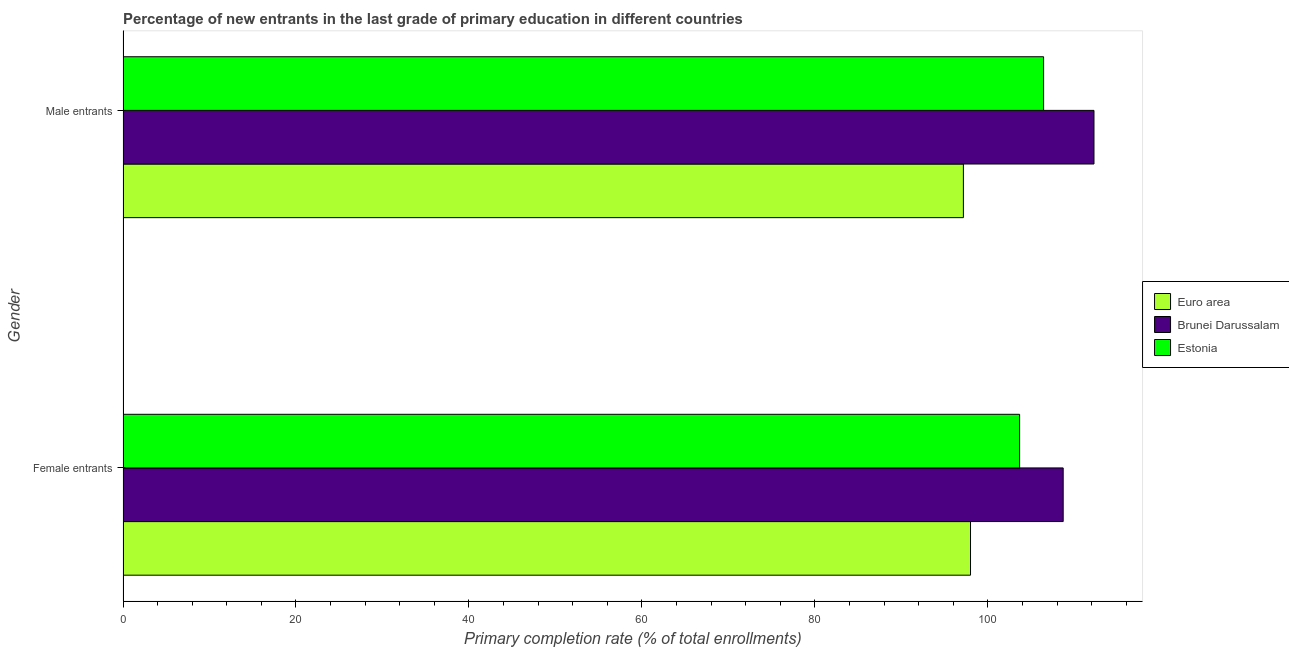How many different coloured bars are there?
Make the answer very short. 3. Are the number of bars per tick equal to the number of legend labels?
Give a very brief answer. Yes. Are the number of bars on each tick of the Y-axis equal?
Your answer should be compact. Yes. How many bars are there on the 2nd tick from the bottom?
Provide a succinct answer. 3. What is the label of the 2nd group of bars from the top?
Your answer should be very brief. Female entrants. What is the primary completion rate of male entrants in Brunei Darussalam?
Make the answer very short. 112.26. Across all countries, what is the maximum primary completion rate of female entrants?
Your answer should be very brief. 108.7. Across all countries, what is the minimum primary completion rate of male entrants?
Provide a succinct answer. 97.16. In which country was the primary completion rate of male entrants maximum?
Make the answer very short. Brunei Darussalam. In which country was the primary completion rate of female entrants minimum?
Offer a very short reply. Euro area. What is the total primary completion rate of female entrants in the graph?
Your response must be concise. 310.34. What is the difference between the primary completion rate of female entrants in Brunei Darussalam and that in Euro area?
Provide a succinct answer. 10.71. What is the difference between the primary completion rate of female entrants in Brunei Darussalam and the primary completion rate of male entrants in Euro area?
Make the answer very short. 11.54. What is the average primary completion rate of female entrants per country?
Keep it short and to the point. 103.45. What is the difference between the primary completion rate of male entrants and primary completion rate of female entrants in Euro area?
Ensure brevity in your answer.  -0.82. What is the ratio of the primary completion rate of female entrants in Estonia to that in Brunei Darussalam?
Offer a terse response. 0.95. In how many countries, is the primary completion rate of female entrants greater than the average primary completion rate of female entrants taken over all countries?
Keep it short and to the point. 2. What does the 1st bar from the top in Female entrants represents?
Offer a very short reply. Estonia. What does the 3rd bar from the bottom in Male entrants represents?
Your response must be concise. Estonia. How many bars are there?
Provide a succinct answer. 6. Are all the bars in the graph horizontal?
Give a very brief answer. Yes. How many countries are there in the graph?
Offer a very short reply. 3. Are the values on the major ticks of X-axis written in scientific E-notation?
Give a very brief answer. No. How many legend labels are there?
Provide a succinct answer. 3. How are the legend labels stacked?
Your answer should be compact. Vertical. What is the title of the graph?
Ensure brevity in your answer.  Percentage of new entrants in the last grade of primary education in different countries. Does "Tajikistan" appear as one of the legend labels in the graph?
Provide a short and direct response. No. What is the label or title of the X-axis?
Offer a very short reply. Primary completion rate (% of total enrollments). What is the label or title of the Y-axis?
Give a very brief answer. Gender. What is the Primary completion rate (% of total enrollments) in Euro area in Female entrants?
Your answer should be compact. 97.98. What is the Primary completion rate (% of total enrollments) in Brunei Darussalam in Female entrants?
Offer a terse response. 108.7. What is the Primary completion rate (% of total enrollments) of Estonia in Female entrants?
Offer a terse response. 103.66. What is the Primary completion rate (% of total enrollments) of Euro area in Male entrants?
Your answer should be very brief. 97.16. What is the Primary completion rate (% of total enrollments) of Brunei Darussalam in Male entrants?
Provide a short and direct response. 112.26. What is the Primary completion rate (% of total enrollments) in Estonia in Male entrants?
Offer a terse response. 106.43. Across all Gender, what is the maximum Primary completion rate (% of total enrollments) of Euro area?
Make the answer very short. 97.98. Across all Gender, what is the maximum Primary completion rate (% of total enrollments) of Brunei Darussalam?
Make the answer very short. 112.26. Across all Gender, what is the maximum Primary completion rate (% of total enrollments) in Estonia?
Ensure brevity in your answer.  106.43. Across all Gender, what is the minimum Primary completion rate (% of total enrollments) in Euro area?
Offer a terse response. 97.16. Across all Gender, what is the minimum Primary completion rate (% of total enrollments) in Brunei Darussalam?
Your answer should be compact. 108.7. Across all Gender, what is the minimum Primary completion rate (% of total enrollments) of Estonia?
Keep it short and to the point. 103.66. What is the total Primary completion rate (% of total enrollments) of Euro area in the graph?
Make the answer very short. 195.14. What is the total Primary completion rate (% of total enrollments) in Brunei Darussalam in the graph?
Your answer should be compact. 220.96. What is the total Primary completion rate (% of total enrollments) of Estonia in the graph?
Keep it short and to the point. 210.09. What is the difference between the Primary completion rate (% of total enrollments) of Euro area in Female entrants and that in Male entrants?
Your response must be concise. 0.82. What is the difference between the Primary completion rate (% of total enrollments) in Brunei Darussalam in Female entrants and that in Male entrants?
Keep it short and to the point. -3.56. What is the difference between the Primary completion rate (% of total enrollments) of Estonia in Female entrants and that in Male entrants?
Provide a short and direct response. -2.77. What is the difference between the Primary completion rate (% of total enrollments) in Euro area in Female entrants and the Primary completion rate (% of total enrollments) in Brunei Darussalam in Male entrants?
Offer a terse response. -14.28. What is the difference between the Primary completion rate (% of total enrollments) in Euro area in Female entrants and the Primary completion rate (% of total enrollments) in Estonia in Male entrants?
Your response must be concise. -8.45. What is the difference between the Primary completion rate (% of total enrollments) in Brunei Darussalam in Female entrants and the Primary completion rate (% of total enrollments) in Estonia in Male entrants?
Provide a succinct answer. 2.27. What is the average Primary completion rate (% of total enrollments) of Euro area per Gender?
Your answer should be compact. 97.57. What is the average Primary completion rate (% of total enrollments) of Brunei Darussalam per Gender?
Keep it short and to the point. 110.48. What is the average Primary completion rate (% of total enrollments) of Estonia per Gender?
Your response must be concise. 105.05. What is the difference between the Primary completion rate (% of total enrollments) of Euro area and Primary completion rate (% of total enrollments) of Brunei Darussalam in Female entrants?
Your answer should be very brief. -10.71. What is the difference between the Primary completion rate (% of total enrollments) in Euro area and Primary completion rate (% of total enrollments) in Estonia in Female entrants?
Provide a succinct answer. -5.68. What is the difference between the Primary completion rate (% of total enrollments) in Brunei Darussalam and Primary completion rate (% of total enrollments) in Estonia in Female entrants?
Give a very brief answer. 5.04. What is the difference between the Primary completion rate (% of total enrollments) of Euro area and Primary completion rate (% of total enrollments) of Brunei Darussalam in Male entrants?
Ensure brevity in your answer.  -15.1. What is the difference between the Primary completion rate (% of total enrollments) of Euro area and Primary completion rate (% of total enrollments) of Estonia in Male entrants?
Make the answer very short. -9.27. What is the difference between the Primary completion rate (% of total enrollments) in Brunei Darussalam and Primary completion rate (% of total enrollments) in Estonia in Male entrants?
Ensure brevity in your answer.  5.83. What is the ratio of the Primary completion rate (% of total enrollments) of Euro area in Female entrants to that in Male entrants?
Your response must be concise. 1.01. What is the ratio of the Primary completion rate (% of total enrollments) of Brunei Darussalam in Female entrants to that in Male entrants?
Provide a succinct answer. 0.97. What is the ratio of the Primary completion rate (% of total enrollments) in Estonia in Female entrants to that in Male entrants?
Make the answer very short. 0.97. What is the difference between the highest and the second highest Primary completion rate (% of total enrollments) of Euro area?
Ensure brevity in your answer.  0.82. What is the difference between the highest and the second highest Primary completion rate (% of total enrollments) in Brunei Darussalam?
Your response must be concise. 3.56. What is the difference between the highest and the second highest Primary completion rate (% of total enrollments) in Estonia?
Give a very brief answer. 2.77. What is the difference between the highest and the lowest Primary completion rate (% of total enrollments) in Euro area?
Keep it short and to the point. 0.82. What is the difference between the highest and the lowest Primary completion rate (% of total enrollments) in Brunei Darussalam?
Your answer should be compact. 3.56. What is the difference between the highest and the lowest Primary completion rate (% of total enrollments) of Estonia?
Offer a very short reply. 2.77. 